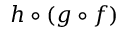Convert formula to latex. <formula><loc_0><loc_0><loc_500><loc_500>h \circ ( g \circ f )</formula> 